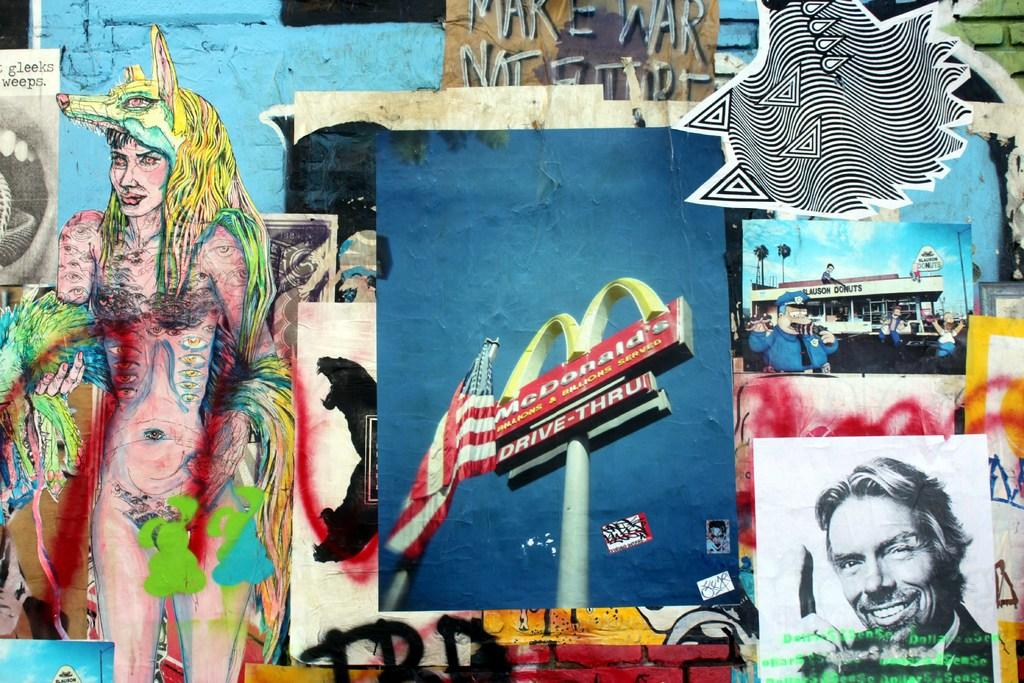What type of artwork is present on the wall in the image? There are paintings and posters on the wall in the image. Can you describe the different types of artwork on the wall? The wall features both paintings and posters. What type of dock can be seen in the image? There is no dock present in the image; it only features paintings and posters on the wall. 